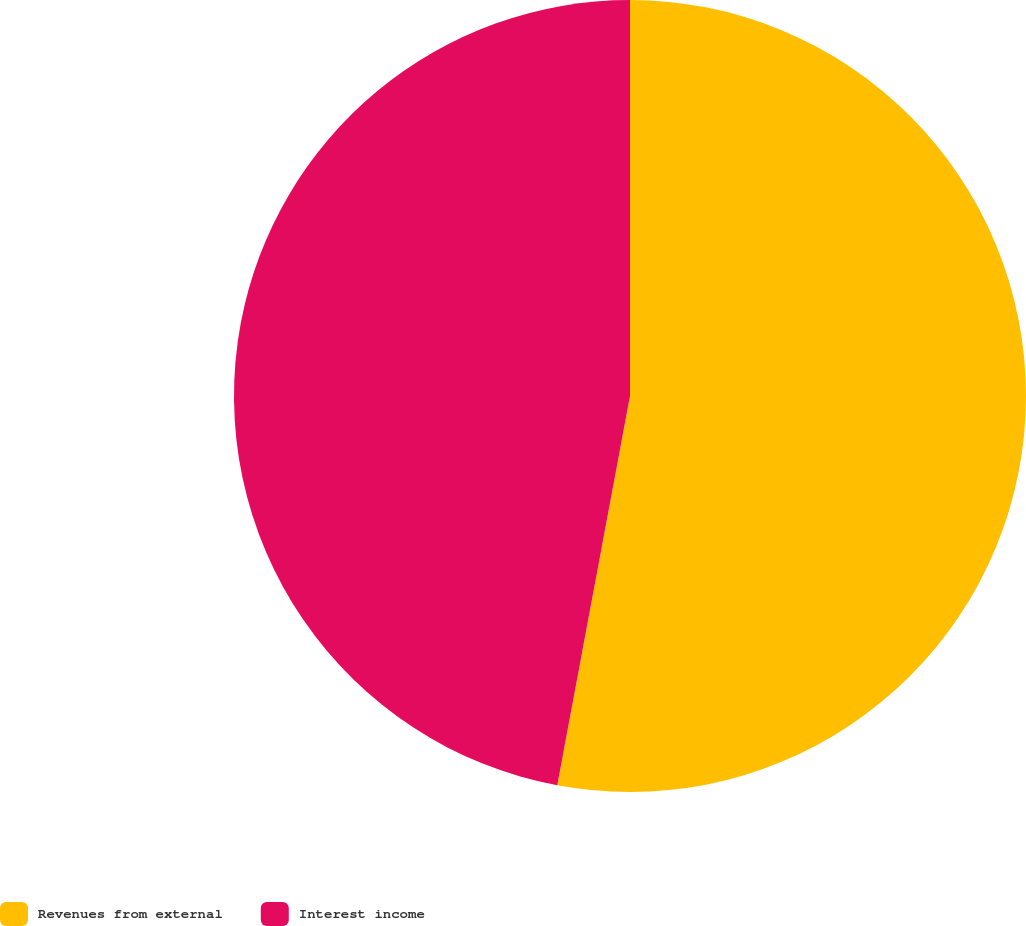Convert chart to OTSL. <chart><loc_0><loc_0><loc_500><loc_500><pie_chart><fcel>Revenues from external<fcel>Interest income<nl><fcel>52.94%<fcel>47.06%<nl></chart> 